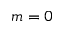Convert formula to latex. <formula><loc_0><loc_0><loc_500><loc_500>m = 0</formula> 